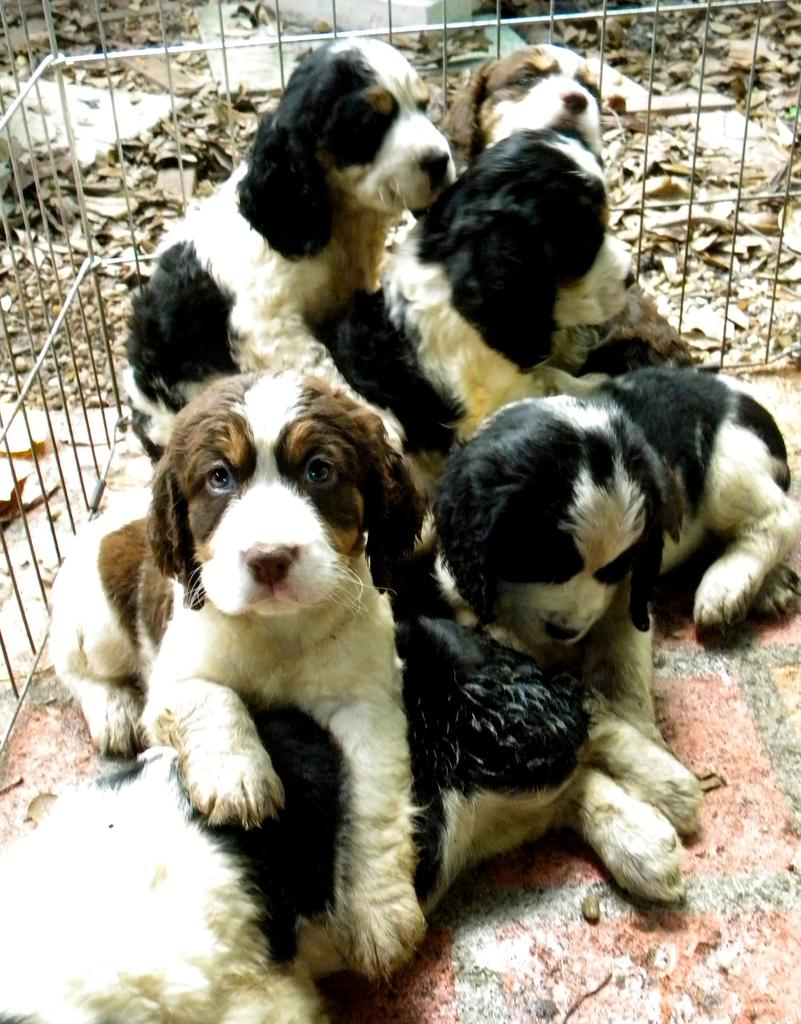What animals are present in the image? There are dogs in the picture. What is surrounding the dogs in the image? There is a fence around the dogs. What can be seen in the background of the picture? There are dried leaves in the background of the picture. What type of treatment is the horse receiving in the image? There is no horse present in the image, so it is not possible to determine what treatment might be given. 